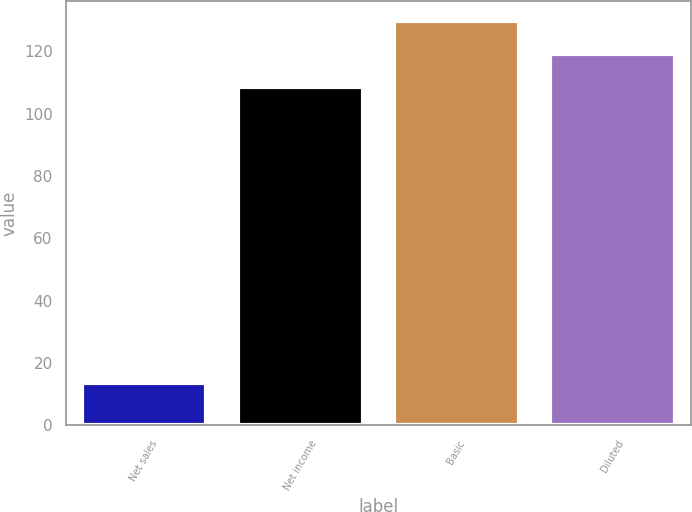Convert chart to OTSL. <chart><loc_0><loc_0><loc_500><loc_500><bar_chart><fcel>Net sales<fcel>Net income<fcel>Basic<fcel>Diluted<nl><fcel>13.6<fcel>108.5<fcel>129.58<fcel>119.04<nl></chart> 